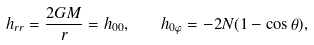<formula> <loc_0><loc_0><loc_500><loc_500>h _ { r r } = \frac { 2 G M } { r } = h _ { 0 0 } , \quad h _ { 0 \varphi } = - 2 N ( 1 - \cos \theta ) ,</formula> 